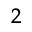<formula> <loc_0><loc_0><loc_500><loc_500>^ { 2 }</formula> 